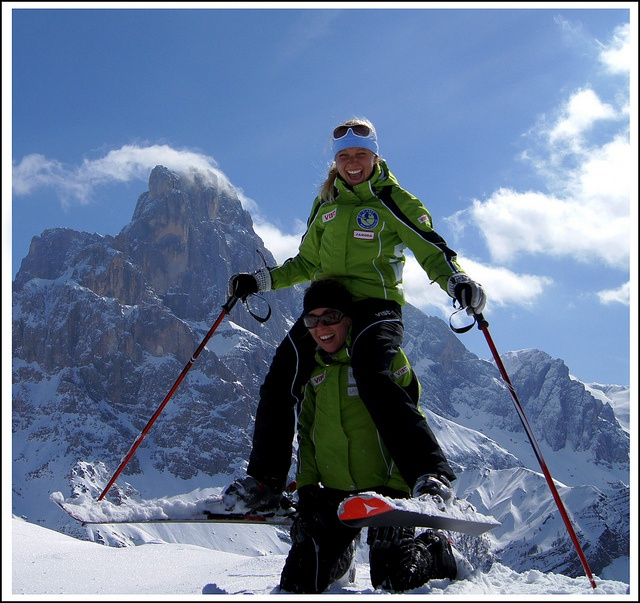Describe the objects in this image and their specific colors. I can see people in black, darkgreen, and gray tones, people in black, darkgreen, maroon, and gray tones, and skis in black, gray, lightgray, and darkgray tones in this image. 